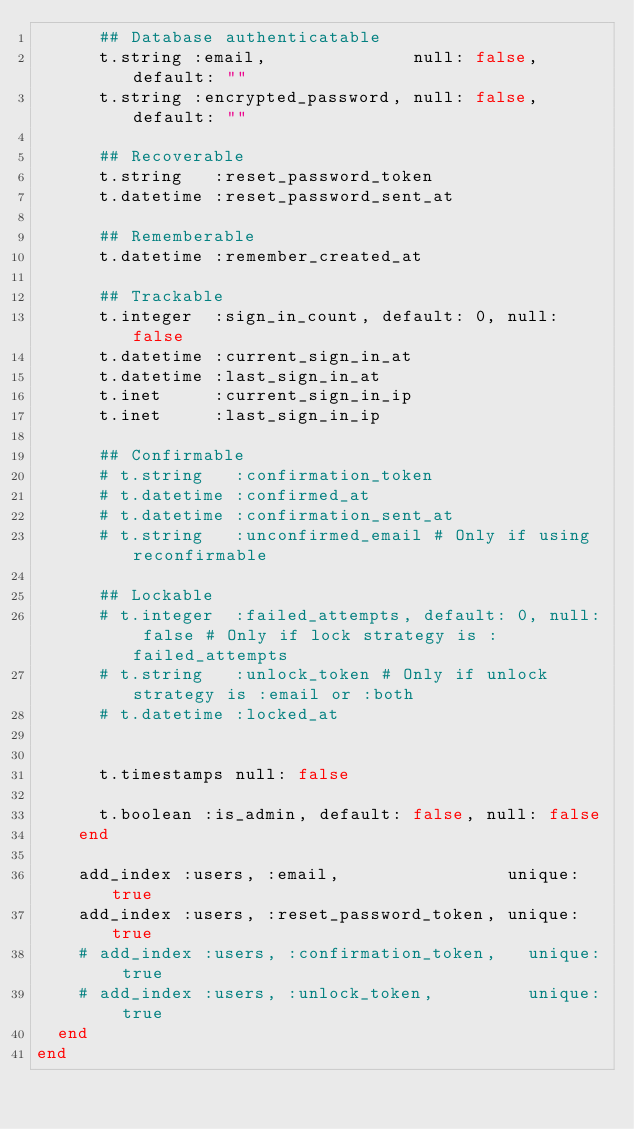Convert code to text. <code><loc_0><loc_0><loc_500><loc_500><_Ruby_>      ## Database authenticatable
      t.string :email,              null: false, default: ""
      t.string :encrypted_password, null: false, default: ""

      ## Recoverable
      t.string   :reset_password_token
      t.datetime :reset_password_sent_at

      ## Rememberable
      t.datetime :remember_created_at

      ## Trackable
      t.integer  :sign_in_count, default: 0, null: false
      t.datetime :current_sign_in_at
      t.datetime :last_sign_in_at
      t.inet     :current_sign_in_ip
      t.inet     :last_sign_in_ip

      ## Confirmable
      # t.string   :confirmation_token
      # t.datetime :confirmed_at
      # t.datetime :confirmation_sent_at
      # t.string   :unconfirmed_email # Only if using reconfirmable

      ## Lockable
      # t.integer  :failed_attempts, default: 0, null: false # Only if lock strategy is :failed_attempts
      # t.string   :unlock_token # Only if unlock strategy is :email or :both
      # t.datetime :locked_at


      t.timestamps null: false

      t.boolean :is_admin, default: false, null: false
    end

    add_index :users, :email,                unique: true
    add_index :users, :reset_password_token, unique: true
    # add_index :users, :confirmation_token,   unique: true
    # add_index :users, :unlock_token,         unique: true
  end
end
</code> 